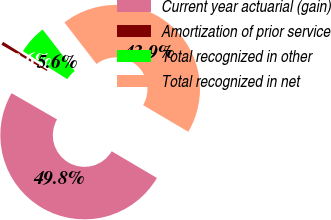Convert chart to OTSL. <chart><loc_0><loc_0><loc_500><loc_500><pie_chart><fcel>Current year actuarial (gain)<fcel>Amortization of prior service<fcel>Total recognized in other<fcel>Total recognized in net<nl><fcel>49.85%<fcel>0.64%<fcel>5.57%<fcel>43.94%<nl></chart> 